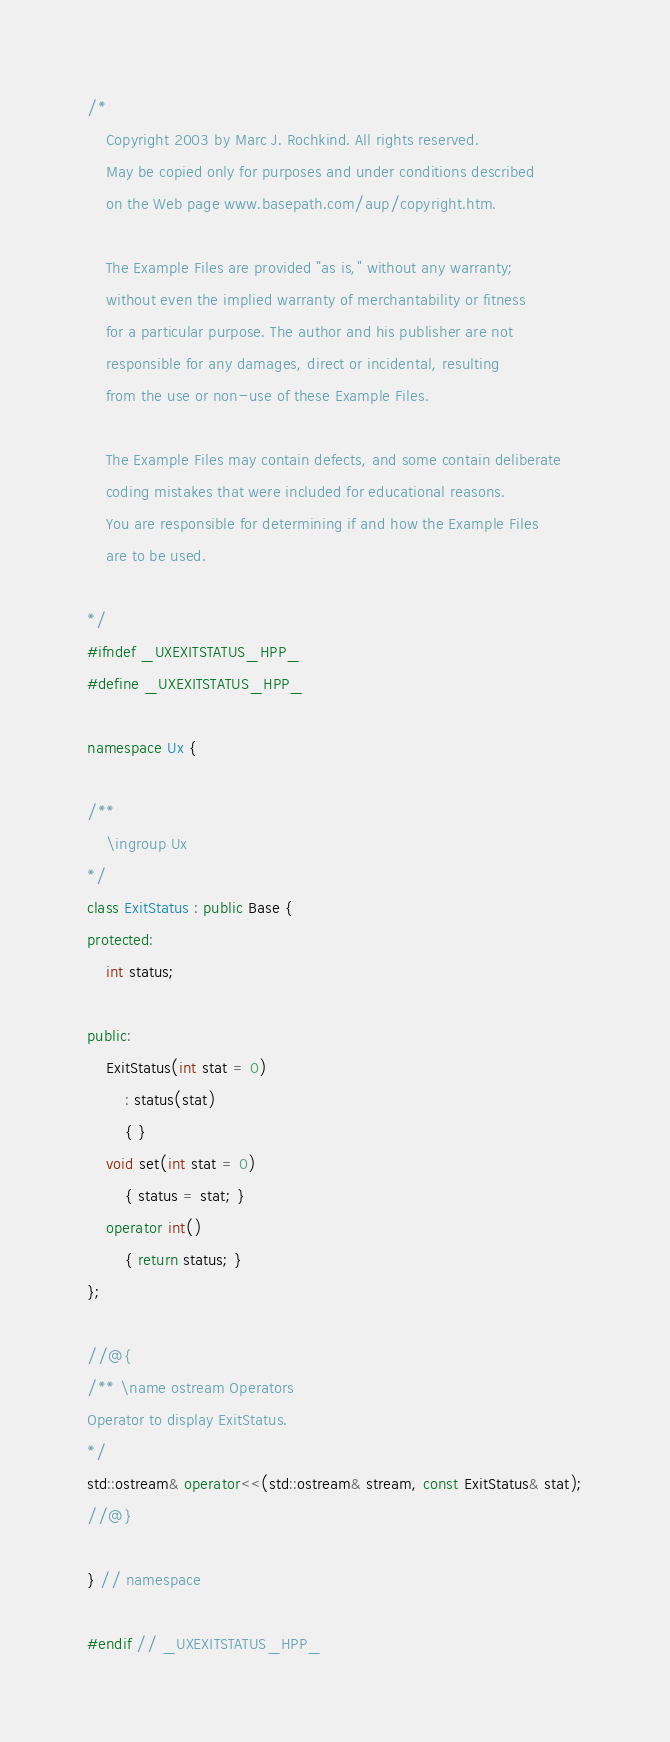<code> <loc_0><loc_0><loc_500><loc_500><_C++_>/*
	Copyright 2003 by Marc J. Rochkind. All rights reserved.
	May be copied only for purposes and under conditions described
	on the Web page www.basepath.com/aup/copyright.htm.

	The Example Files are provided "as is," without any warranty;
	without even the implied warranty of merchantability or fitness
	for a particular purpose. The author and his publisher are not
	responsible for any damages, direct or incidental, resulting
	from the use or non-use of these Example Files.

	The Example Files may contain defects, and some contain deliberate
	coding mistakes that were included for educational reasons.
	You are responsible for determining if and how the Example Files
	are to be used.

*/
#ifndef _UXEXITSTATUS_HPP_
#define _UXEXITSTATUS_HPP_

namespace Ux {

/**
	\ingroup Ux
*/
class ExitStatus : public Base {
protected:
	int status;

public:
	ExitStatus(int stat = 0)
		: status(stat)
		{ }
	void set(int stat = 0)
		{ status = stat; }
	operator int()
		{ return status; }
};

//@{
/** \name ostream Operators
Operator to display ExitStatus.
*/
std::ostream& operator<<(std::ostream& stream, const ExitStatus& stat);
//@}

} // namespace

#endif // _UXEXITSTATUS_HPP_
</code> 